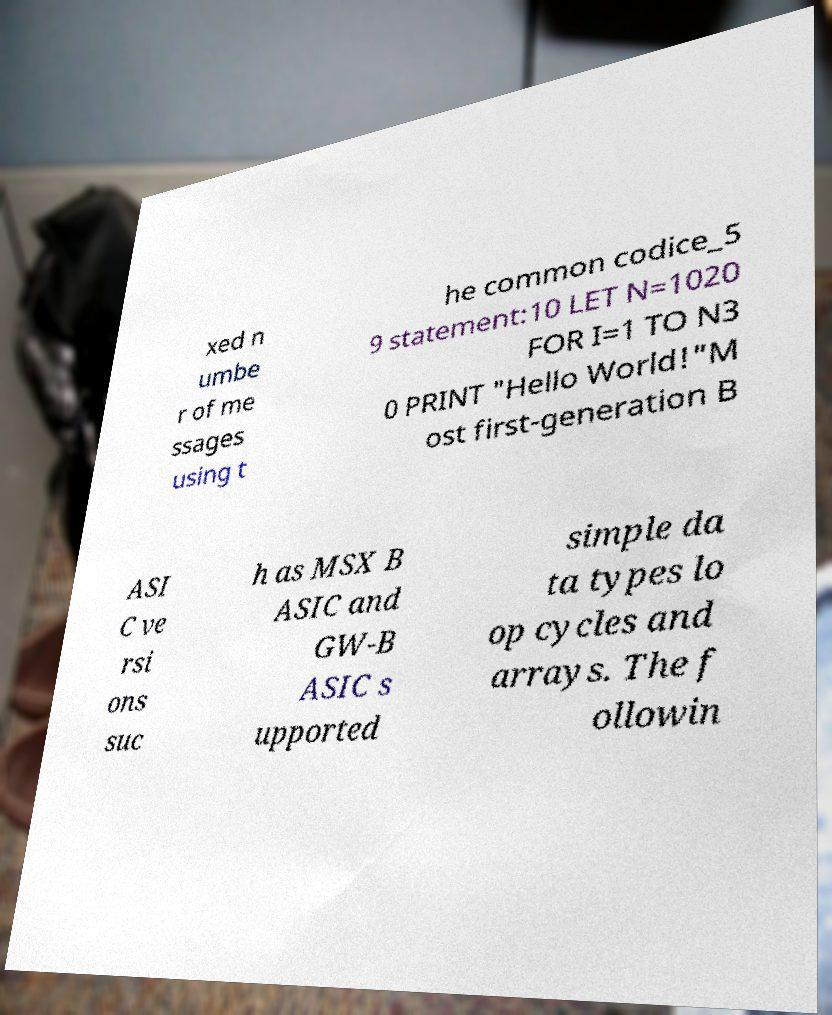Could you extract and type out the text from this image? xed n umbe r of me ssages using t he common codice_5 9 statement:10 LET N=1020 FOR I=1 TO N3 0 PRINT "Hello World!"M ost first-generation B ASI C ve rsi ons suc h as MSX B ASIC and GW-B ASIC s upported simple da ta types lo op cycles and arrays. The f ollowin 